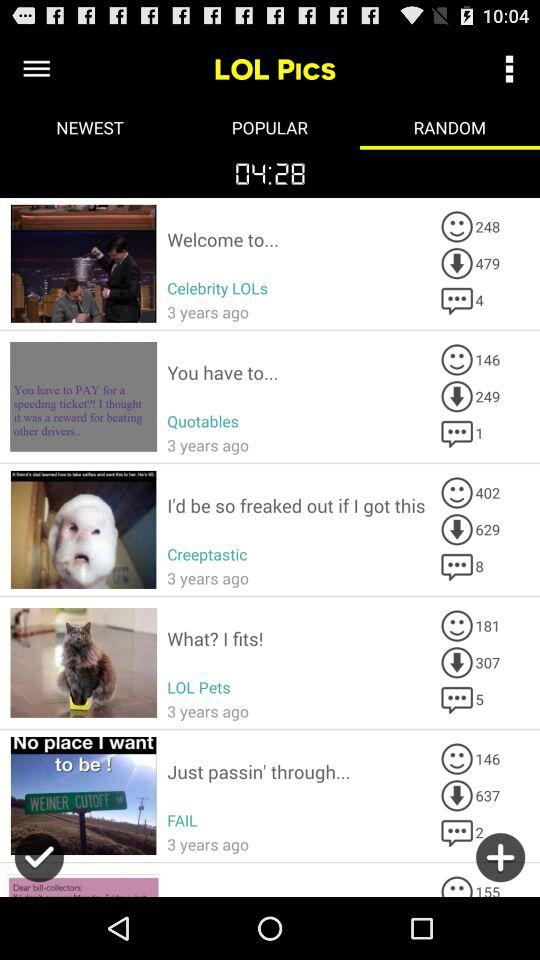How many people have downloaded the "LOL Pets" pic? The people who have downloaded the "LOL Pets" pic is 307. 